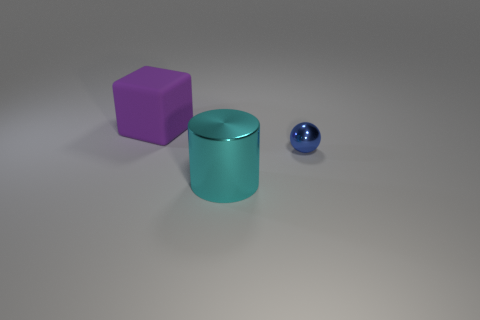There is a cyan metallic thing that is the same size as the purple rubber thing; what is its shape?
Your answer should be very brief. Cylinder. There is a thing on the right side of the cyan thing; what color is it?
Your response must be concise. Blue. There is a large thing that is behind the tiny blue sphere; are there any small blue metal balls to the left of it?
Your answer should be compact. No. What number of things are either things that are in front of the cube or large green shiny cylinders?
Provide a short and direct response. 2. Are there any other things that have the same size as the blue sphere?
Your answer should be very brief. No. There is a large thing that is left of the big thing in front of the large rubber thing; what is its material?
Provide a succinct answer. Rubber. Is the number of purple matte things right of the big purple thing the same as the number of cyan cylinders that are in front of the blue sphere?
Provide a short and direct response. No. What number of objects are either big objects on the right side of the purple cube or big objects that are to the left of the cylinder?
Provide a short and direct response. 2. What is the material of the thing that is both behind the large cyan cylinder and on the left side of the tiny metallic thing?
Ensure brevity in your answer.  Rubber. There is a metallic thing in front of the thing that is right of the large thing right of the block; what is its size?
Your answer should be compact. Large. 